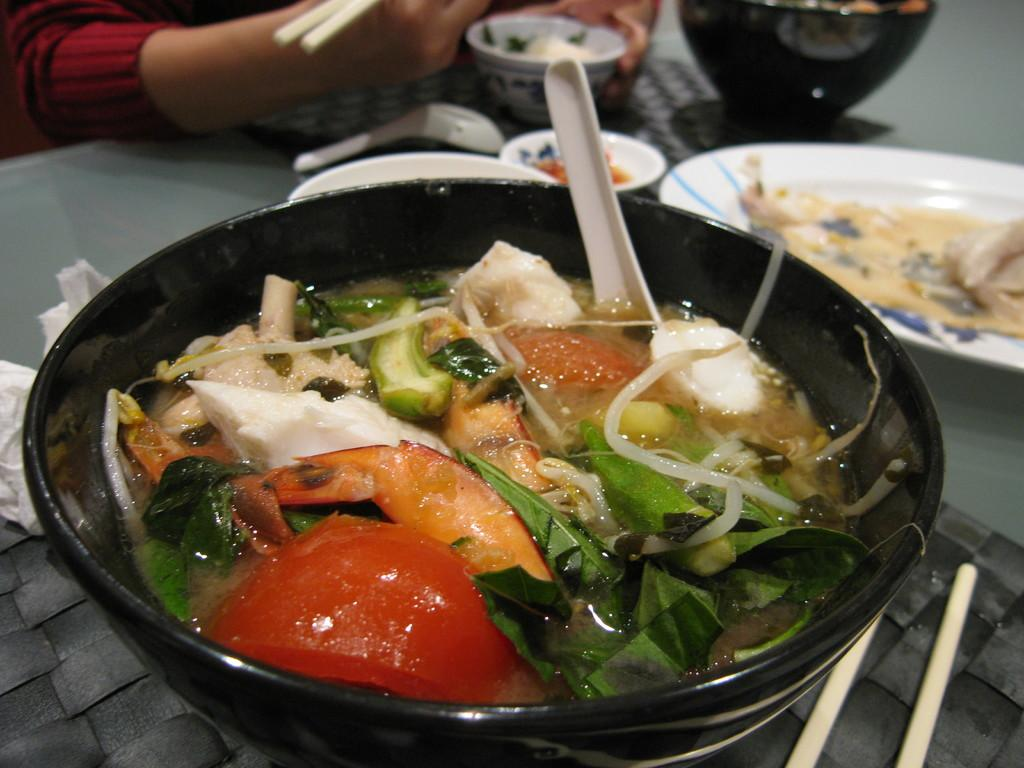What is the person in the image doing? The person is sitting on a chair in the image. What is the person holding in the image? The person is holding chopsticks. What is in the serving bowl in the image? There is food in the serving bowl in the image. Where is the serving bowl placed in the image? The serving bowl is placed on a table in the image. What type of skin can be seen on the person's hands in the image? There is no information about the person's skin in the image, as it does not focus on the person's hands or any other body part. 